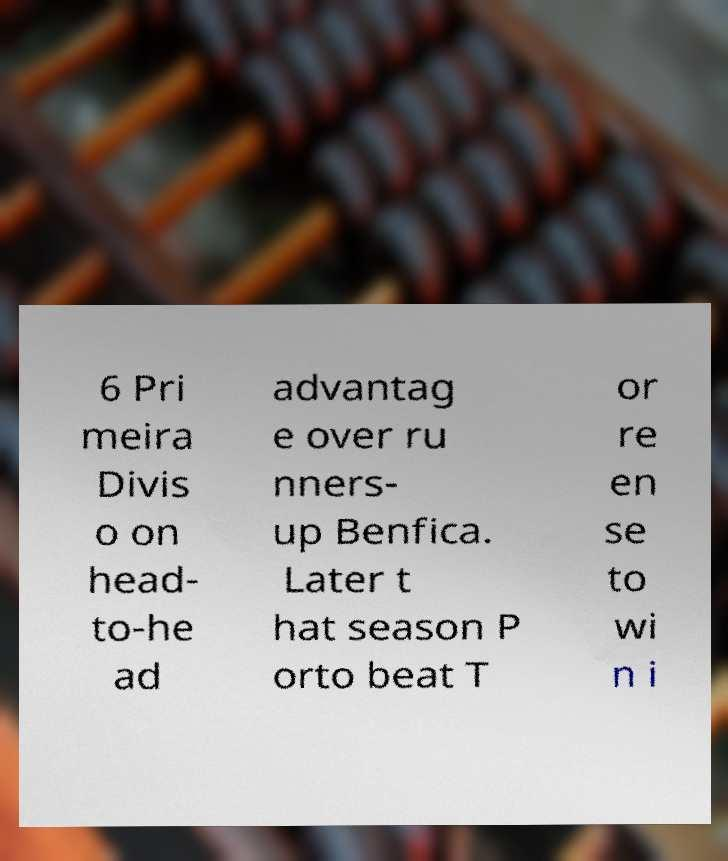For documentation purposes, I need the text within this image transcribed. Could you provide that? 6 Pri meira Divis o on head- to-he ad advantag e over ru nners- up Benfica. Later t hat season P orto beat T or re en se to wi n i 